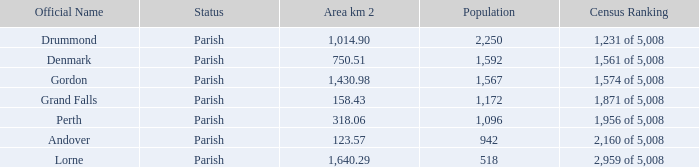What is the area of the parish with a population larger than 1,172 and a census ranking of 1,871 of 5,008? 0.0. 